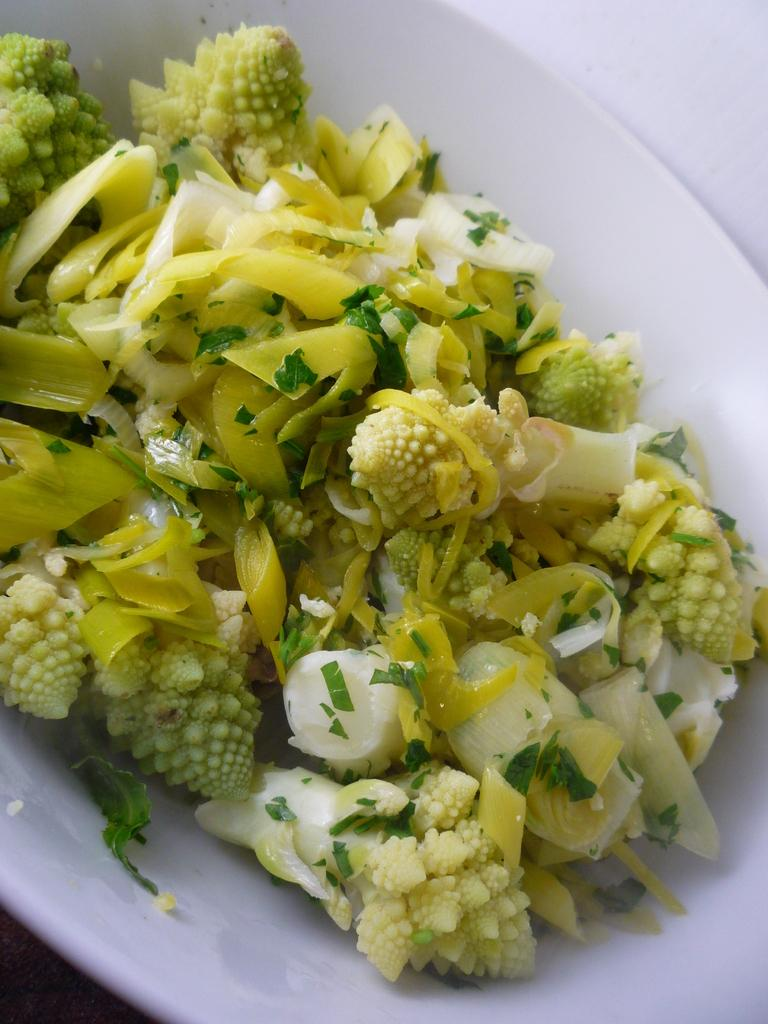What is on the plate that is visible in the image? There is food on a plate in the image. What color is the background of the image? The background of the image is white. What type of insurance is being discussed in the image? There is no discussion of insurance in the image; it only features food on a plate and a white background. 